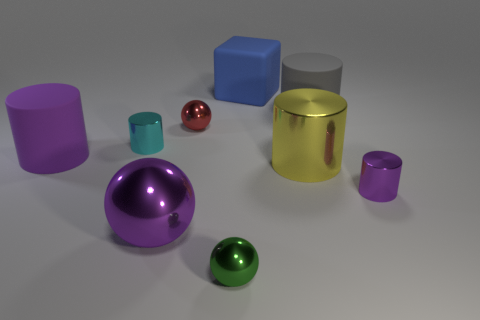Subtract all red metallic balls. How many balls are left? 2 Subtract all spheres. How many objects are left? 6 Subtract all red balls. How many balls are left? 2 Subtract 2 cylinders. How many cylinders are left? 3 Subtract all blue spheres. How many purple cylinders are left? 2 Add 8 purple balls. How many purple balls are left? 9 Add 9 large yellow shiny objects. How many large yellow shiny objects exist? 10 Subtract 1 blue blocks. How many objects are left? 8 Subtract all purple cylinders. Subtract all green cubes. How many cylinders are left? 3 Subtract all large purple cylinders. Subtract all tiny cyan cylinders. How many objects are left? 7 